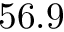Convert formula to latex. <formula><loc_0><loc_0><loc_500><loc_500>5 6 . 9</formula> 